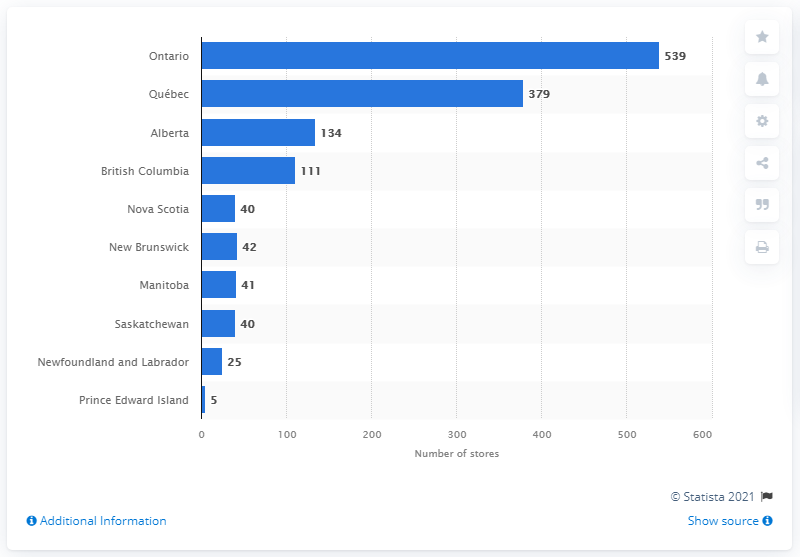Draw attention to some important aspects in this diagram. As of January 2021, there were 539 Dollarama stores operating in Ontario. According to the data, Prince Edward Island had the lowest number of Dollarama stores out of all the provinces in Canada. 